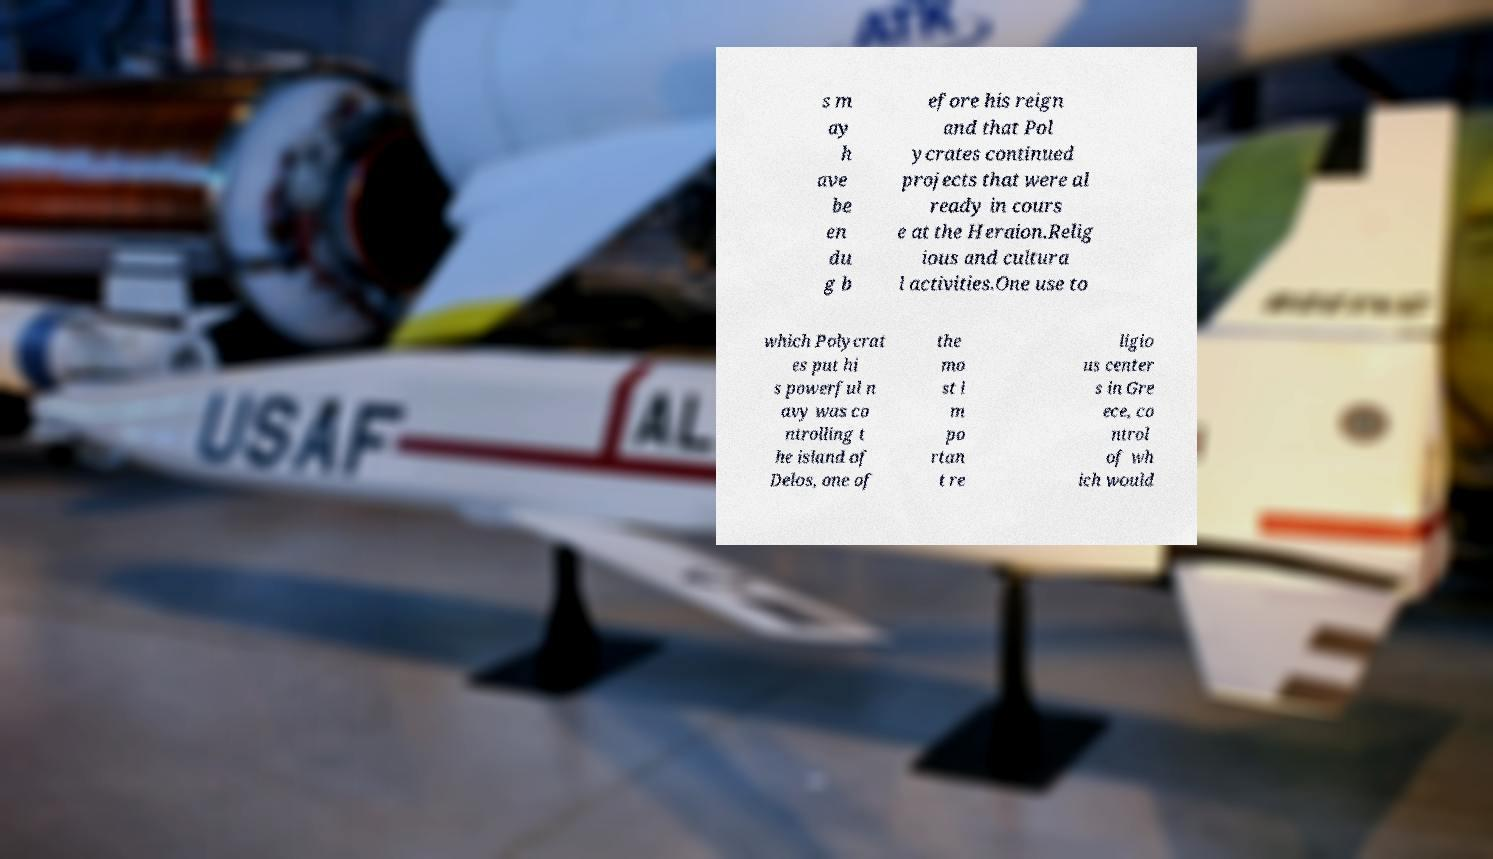Can you read and provide the text displayed in the image?This photo seems to have some interesting text. Can you extract and type it out for me? s m ay h ave be en du g b efore his reign and that Pol ycrates continued projects that were al ready in cours e at the Heraion.Relig ious and cultura l activities.One use to which Polycrat es put hi s powerful n avy was co ntrolling t he island of Delos, one of the mo st i m po rtan t re ligio us center s in Gre ece, co ntrol of wh ich would 